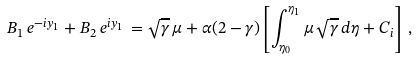Convert formula to latex. <formula><loc_0><loc_0><loc_500><loc_500>B _ { 1 } \, e ^ { - i y _ { 1 } } + B _ { 2 } \, e ^ { i y _ { 1 } } \, = \sqrt { \gamma } \, \mu + \alpha ( 2 - \gamma ) \left [ \int _ { \eta _ { 0 } } ^ { \eta _ { 1 } } \mu \, \sqrt { \gamma } \, d \eta + C _ { i } \right ] \, ,</formula> 